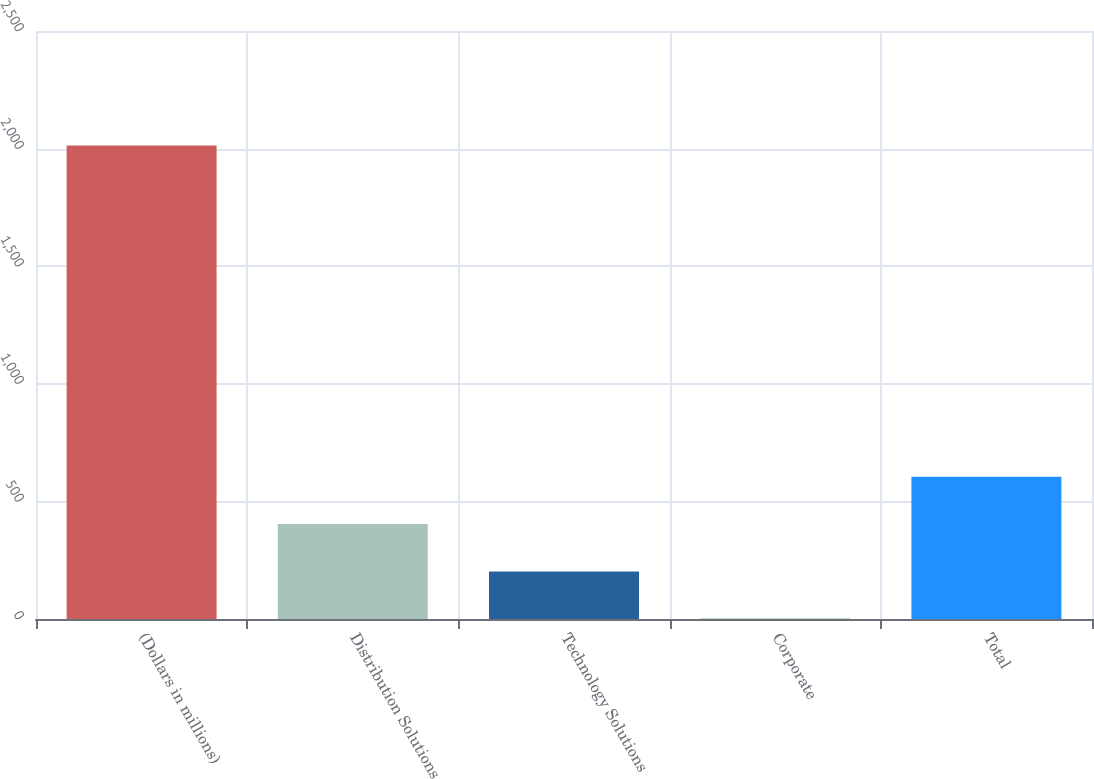Convert chart to OTSL. <chart><loc_0><loc_0><loc_500><loc_500><bar_chart><fcel>(Dollars in millions)<fcel>Distribution Solutions<fcel>Technology Solutions<fcel>Corporate<fcel>Total<nl><fcel>2013<fcel>403.4<fcel>202.2<fcel>1<fcel>604.6<nl></chart> 